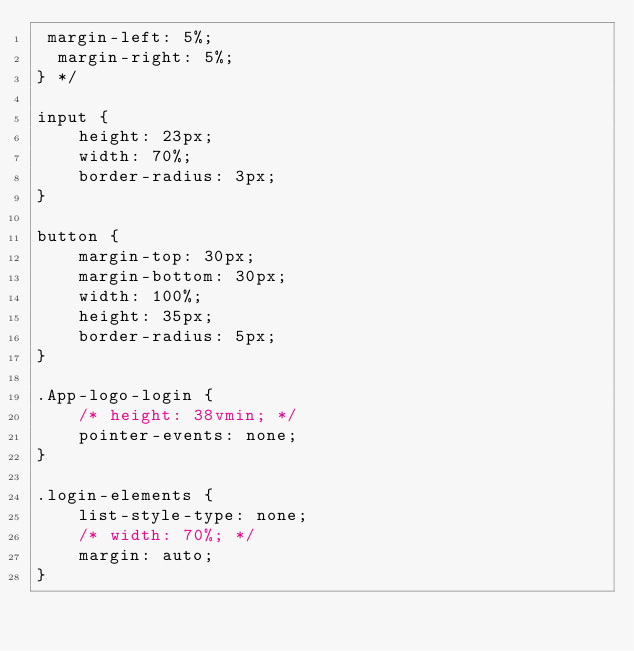Convert code to text. <code><loc_0><loc_0><loc_500><loc_500><_CSS_> margin-left: 5%;
  margin-right: 5%;
} */

input {
    height: 23px;
    width: 70%;
    border-radius: 3px;
}

button {
    margin-top: 30px;
    margin-bottom: 30px;
    width: 100%;
    height: 35px;
    border-radius: 5px;
}

.App-logo-login {
    /* height: 38vmin; */
    pointer-events: none;
}

.login-elements {
    list-style-type: none;
    /* width: 70%; */
    margin: auto;
}</code> 